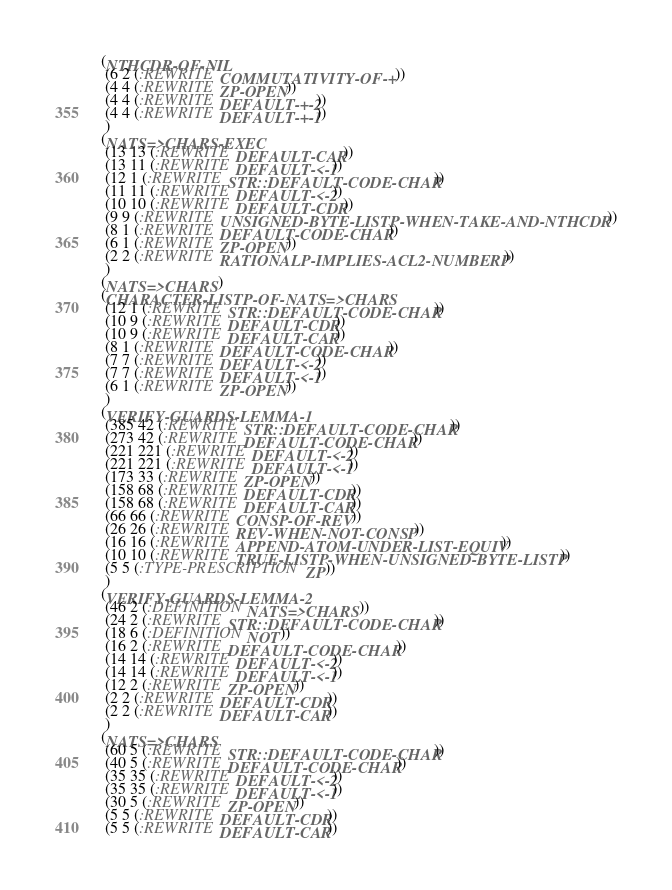<code> <loc_0><loc_0><loc_500><loc_500><_Lisp_>(NTHCDR-OF-NIL
 (6 2 (:REWRITE COMMUTATIVITY-OF-+))
 (4 4 (:REWRITE ZP-OPEN))
 (4 4 (:REWRITE DEFAULT-+-2))
 (4 4 (:REWRITE DEFAULT-+-1))
 )
(NATS=>CHARS-EXEC
 (13 13 (:REWRITE DEFAULT-CAR))
 (13 11 (:REWRITE DEFAULT-<-1))
 (12 1 (:REWRITE STR::DEFAULT-CODE-CHAR))
 (11 11 (:REWRITE DEFAULT-<-2))
 (10 10 (:REWRITE DEFAULT-CDR))
 (9 9 (:REWRITE UNSIGNED-BYTE-LISTP-WHEN-TAKE-AND-NTHCDR))
 (8 1 (:REWRITE DEFAULT-CODE-CHAR))
 (6 1 (:REWRITE ZP-OPEN))
 (2 2 (:REWRITE RATIONALP-IMPLIES-ACL2-NUMBERP))
 )
(NATS=>CHARS)
(CHARACTER-LISTP-OF-NATS=>CHARS
 (12 1 (:REWRITE STR::DEFAULT-CODE-CHAR))
 (10 9 (:REWRITE DEFAULT-CDR))
 (10 9 (:REWRITE DEFAULT-CAR))
 (8 1 (:REWRITE DEFAULT-CODE-CHAR))
 (7 7 (:REWRITE DEFAULT-<-2))
 (7 7 (:REWRITE DEFAULT-<-1))
 (6 1 (:REWRITE ZP-OPEN))
 )
(VERIFY-GUARDS-LEMMA-1
 (385 42 (:REWRITE STR::DEFAULT-CODE-CHAR))
 (273 42 (:REWRITE DEFAULT-CODE-CHAR))
 (221 221 (:REWRITE DEFAULT-<-2))
 (221 221 (:REWRITE DEFAULT-<-1))
 (173 33 (:REWRITE ZP-OPEN))
 (158 68 (:REWRITE DEFAULT-CDR))
 (158 68 (:REWRITE DEFAULT-CAR))
 (66 66 (:REWRITE CONSP-OF-REV))
 (26 26 (:REWRITE REV-WHEN-NOT-CONSP))
 (16 16 (:REWRITE APPEND-ATOM-UNDER-LIST-EQUIV))
 (10 10 (:REWRITE TRUE-LISTP-WHEN-UNSIGNED-BYTE-LISTP))
 (5 5 (:TYPE-PRESCRIPTION ZP))
 )
(VERIFY-GUARDS-LEMMA-2
 (46 2 (:DEFINITION NATS=>CHARS))
 (24 2 (:REWRITE STR::DEFAULT-CODE-CHAR))
 (18 6 (:DEFINITION NOT))
 (16 2 (:REWRITE DEFAULT-CODE-CHAR))
 (14 14 (:REWRITE DEFAULT-<-2))
 (14 14 (:REWRITE DEFAULT-<-1))
 (12 2 (:REWRITE ZP-OPEN))
 (2 2 (:REWRITE DEFAULT-CDR))
 (2 2 (:REWRITE DEFAULT-CAR))
 )
(NATS=>CHARS
 (60 5 (:REWRITE STR::DEFAULT-CODE-CHAR))
 (40 5 (:REWRITE DEFAULT-CODE-CHAR))
 (35 35 (:REWRITE DEFAULT-<-2))
 (35 35 (:REWRITE DEFAULT-<-1))
 (30 5 (:REWRITE ZP-OPEN))
 (5 5 (:REWRITE DEFAULT-CDR))
 (5 5 (:REWRITE DEFAULT-CAR))</code> 